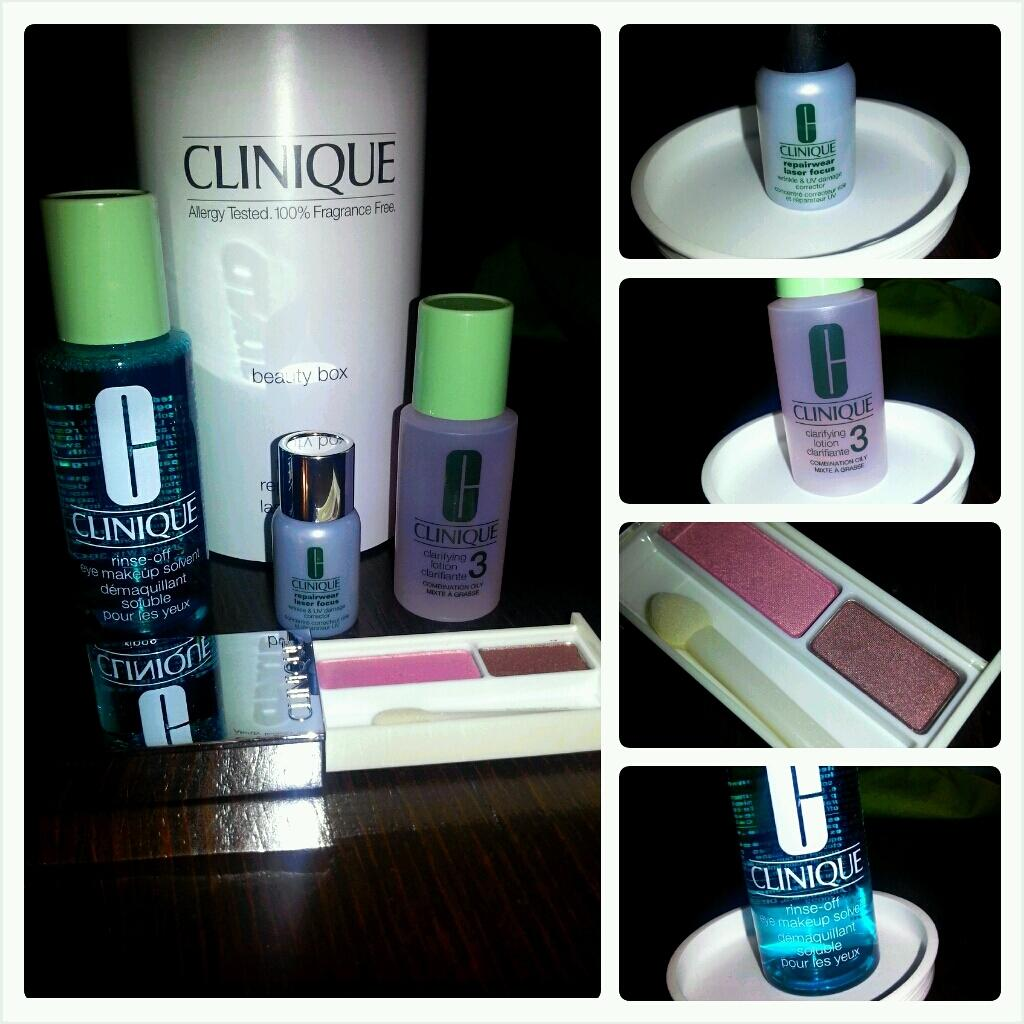Provide a one-sentence caption for the provided image. Several bottles of Clinique makeup  next to each other on a wooden table. 